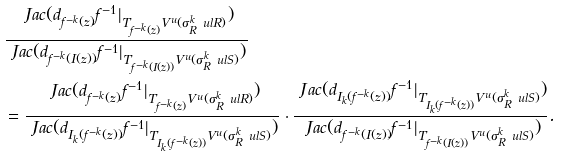Convert formula to latex. <formula><loc_0><loc_0><loc_500><loc_500>& \frac { \ J a c ( d _ { f ^ { - k } ( z ) } f ^ { - 1 } | _ { T _ { f ^ { - k } ( z ) } V ^ { u } ( \sigma _ { R } ^ { k } \ u l { R } ) } ) } { \ J a c ( d _ { f ^ { - k } ( I ( z ) ) } f ^ { - 1 } | _ { T _ { f ^ { - k } ( I ( z ) ) } V ^ { u } ( \sigma _ { R } ^ { k } \ u l { S } ) } ) } \\ & = \frac { \ J a c ( d _ { f ^ { - k } ( z ) } f ^ { - 1 } | _ { T _ { f ^ { - k } ( z ) } V ^ { u } ( \sigma _ { R } ^ { k } \ u l { R } ) } ) } { \ J a c ( d _ { I _ { k } ( f ^ { - k } ( z ) ) } f ^ { - 1 } | _ { T _ { I _ { k } ( f ^ { - k } ( z ) ) } V ^ { u } ( \sigma _ { R } ^ { k } \ u l { S } ) } ) } \cdot \frac { \ J a c ( d _ { I _ { k } ( f ^ { - k } ( z ) ) } f ^ { - 1 } | _ { T _ { I _ { k } ( f ^ { - k } ( z ) ) } V ^ { u } ( \sigma _ { R } ^ { k } \ u l { S } ) } ) } { \ J a c ( d _ { f ^ { - k } ( I ( z ) ) } f ^ { - 1 } | _ { T _ { f ^ { - k } ( I ( z ) ) } V ^ { u } ( \sigma _ { R } ^ { k } \ u l { S } ) } ) } .</formula> 